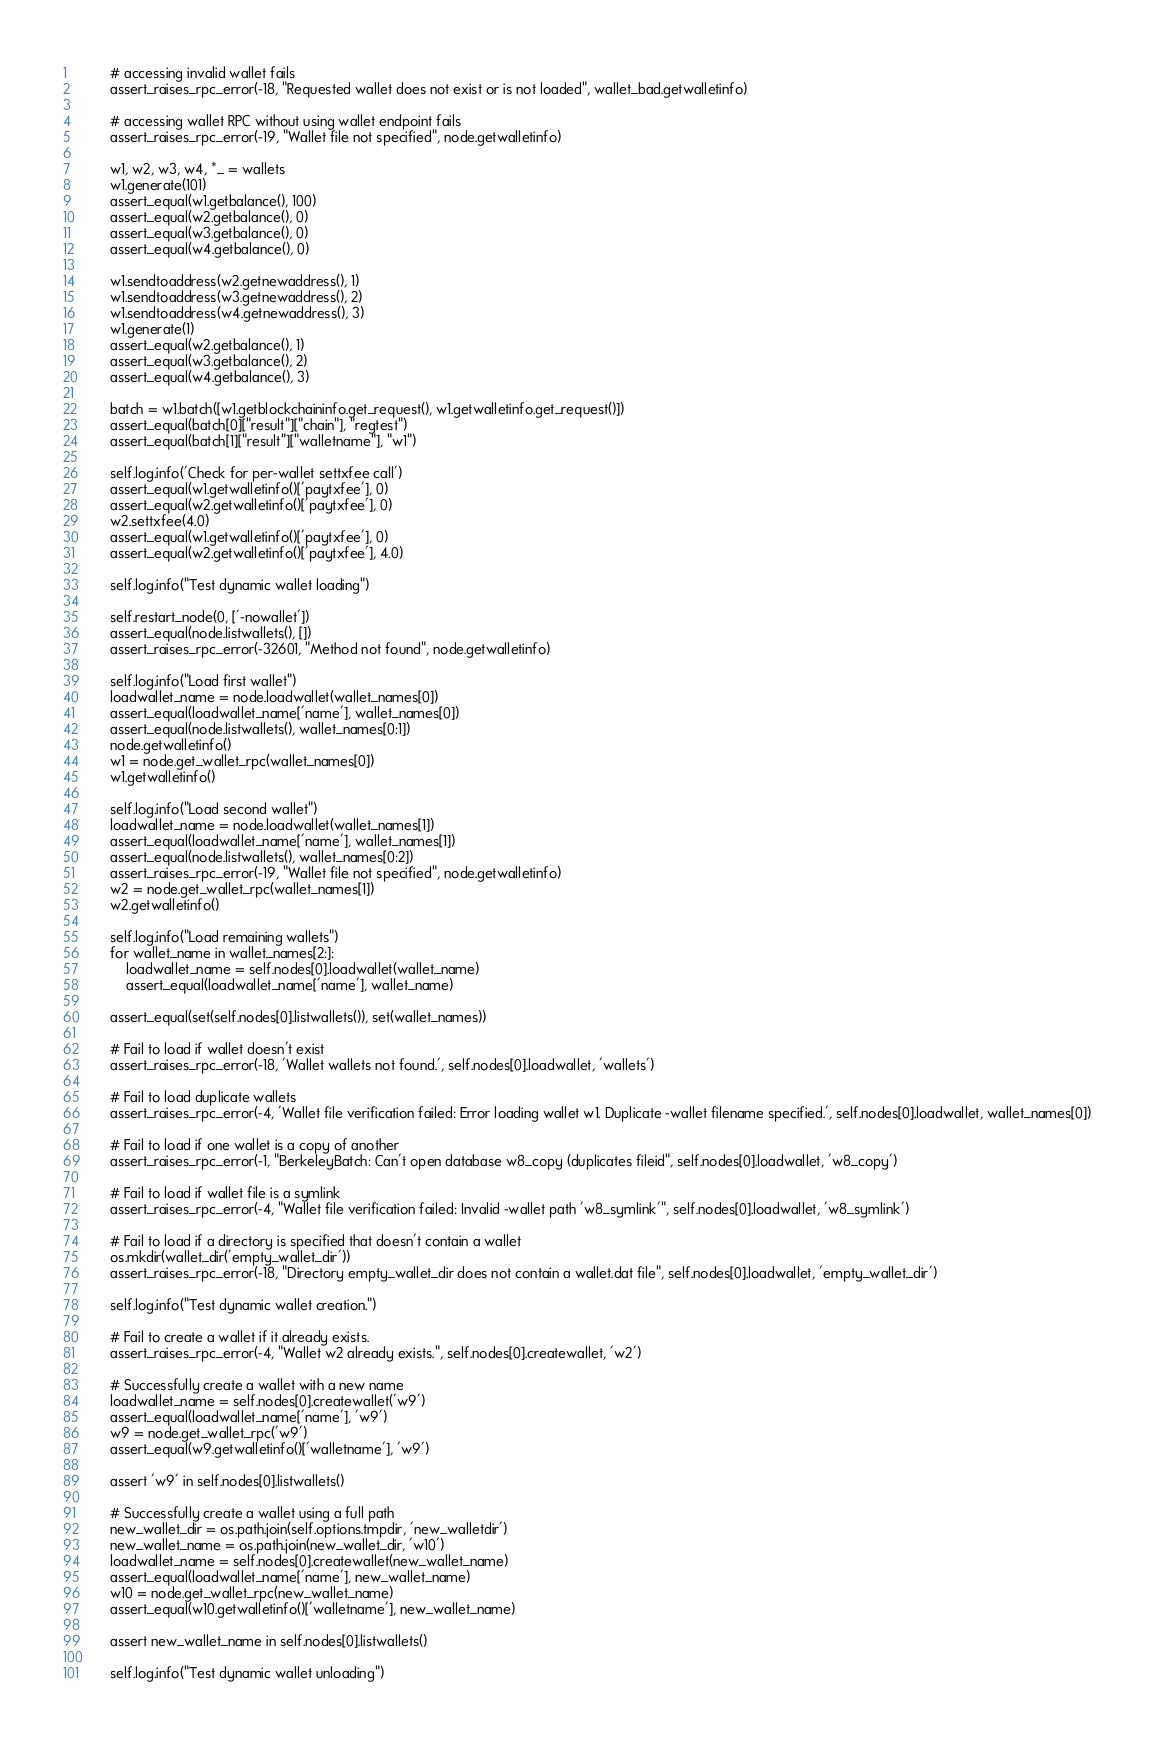Convert code to text. <code><loc_0><loc_0><loc_500><loc_500><_Python_>
        # accessing invalid wallet fails
        assert_raises_rpc_error(-18, "Requested wallet does not exist or is not loaded", wallet_bad.getwalletinfo)

        # accessing wallet RPC without using wallet endpoint fails
        assert_raises_rpc_error(-19, "Wallet file not specified", node.getwalletinfo)

        w1, w2, w3, w4, *_ = wallets
        w1.generate(101)
        assert_equal(w1.getbalance(), 100)
        assert_equal(w2.getbalance(), 0)
        assert_equal(w3.getbalance(), 0)
        assert_equal(w4.getbalance(), 0)

        w1.sendtoaddress(w2.getnewaddress(), 1)
        w1.sendtoaddress(w3.getnewaddress(), 2)
        w1.sendtoaddress(w4.getnewaddress(), 3)
        w1.generate(1)
        assert_equal(w2.getbalance(), 1)
        assert_equal(w3.getbalance(), 2)
        assert_equal(w4.getbalance(), 3)

        batch = w1.batch([w1.getblockchaininfo.get_request(), w1.getwalletinfo.get_request()])
        assert_equal(batch[0]["result"]["chain"], "regtest")
        assert_equal(batch[1]["result"]["walletname"], "w1")

        self.log.info('Check for per-wallet settxfee call')
        assert_equal(w1.getwalletinfo()['paytxfee'], 0)
        assert_equal(w2.getwalletinfo()['paytxfee'], 0)
        w2.settxfee(4.0)
        assert_equal(w1.getwalletinfo()['paytxfee'], 0)
        assert_equal(w2.getwalletinfo()['paytxfee'], 4.0)

        self.log.info("Test dynamic wallet loading")

        self.restart_node(0, ['-nowallet'])
        assert_equal(node.listwallets(), [])
        assert_raises_rpc_error(-32601, "Method not found", node.getwalletinfo)

        self.log.info("Load first wallet")
        loadwallet_name = node.loadwallet(wallet_names[0])
        assert_equal(loadwallet_name['name'], wallet_names[0])
        assert_equal(node.listwallets(), wallet_names[0:1])
        node.getwalletinfo()
        w1 = node.get_wallet_rpc(wallet_names[0])
        w1.getwalletinfo()

        self.log.info("Load second wallet")
        loadwallet_name = node.loadwallet(wallet_names[1])
        assert_equal(loadwallet_name['name'], wallet_names[1])
        assert_equal(node.listwallets(), wallet_names[0:2])
        assert_raises_rpc_error(-19, "Wallet file not specified", node.getwalletinfo)
        w2 = node.get_wallet_rpc(wallet_names[1])
        w2.getwalletinfo()

        self.log.info("Load remaining wallets")
        for wallet_name in wallet_names[2:]:
            loadwallet_name = self.nodes[0].loadwallet(wallet_name)
            assert_equal(loadwallet_name['name'], wallet_name)

        assert_equal(set(self.nodes[0].listwallets()), set(wallet_names))

        # Fail to load if wallet doesn't exist
        assert_raises_rpc_error(-18, 'Wallet wallets not found.', self.nodes[0].loadwallet, 'wallets')

        # Fail to load duplicate wallets
        assert_raises_rpc_error(-4, 'Wallet file verification failed: Error loading wallet w1. Duplicate -wallet filename specified.', self.nodes[0].loadwallet, wallet_names[0])

        # Fail to load if one wallet is a copy of another
        assert_raises_rpc_error(-1, "BerkeleyBatch: Can't open database w8_copy (duplicates fileid", self.nodes[0].loadwallet, 'w8_copy')

        # Fail to load if wallet file is a symlink
        assert_raises_rpc_error(-4, "Wallet file verification failed: Invalid -wallet path 'w8_symlink'", self.nodes[0].loadwallet, 'w8_symlink')

        # Fail to load if a directory is specified that doesn't contain a wallet
        os.mkdir(wallet_dir('empty_wallet_dir'))
        assert_raises_rpc_error(-18, "Directory empty_wallet_dir does not contain a wallet.dat file", self.nodes[0].loadwallet, 'empty_wallet_dir')

        self.log.info("Test dynamic wallet creation.")

        # Fail to create a wallet if it already exists.
        assert_raises_rpc_error(-4, "Wallet w2 already exists.", self.nodes[0].createwallet, 'w2')

        # Successfully create a wallet with a new name
        loadwallet_name = self.nodes[0].createwallet('w9')
        assert_equal(loadwallet_name['name'], 'w9')
        w9 = node.get_wallet_rpc('w9')
        assert_equal(w9.getwalletinfo()['walletname'], 'w9')

        assert 'w9' in self.nodes[0].listwallets()

        # Successfully create a wallet using a full path
        new_wallet_dir = os.path.join(self.options.tmpdir, 'new_walletdir')
        new_wallet_name = os.path.join(new_wallet_dir, 'w10')
        loadwallet_name = self.nodes[0].createwallet(new_wallet_name)
        assert_equal(loadwallet_name['name'], new_wallet_name)
        w10 = node.get_wallet_rpc(new_wallet_name)
        assert_equal(w10.getwalletinfo()['walletname'], new_wallet_name)

        assert new_wallet_name in self.nodes[0].listwallets()

        self.log.info("Test dynamic wallet unloading")
</code> 